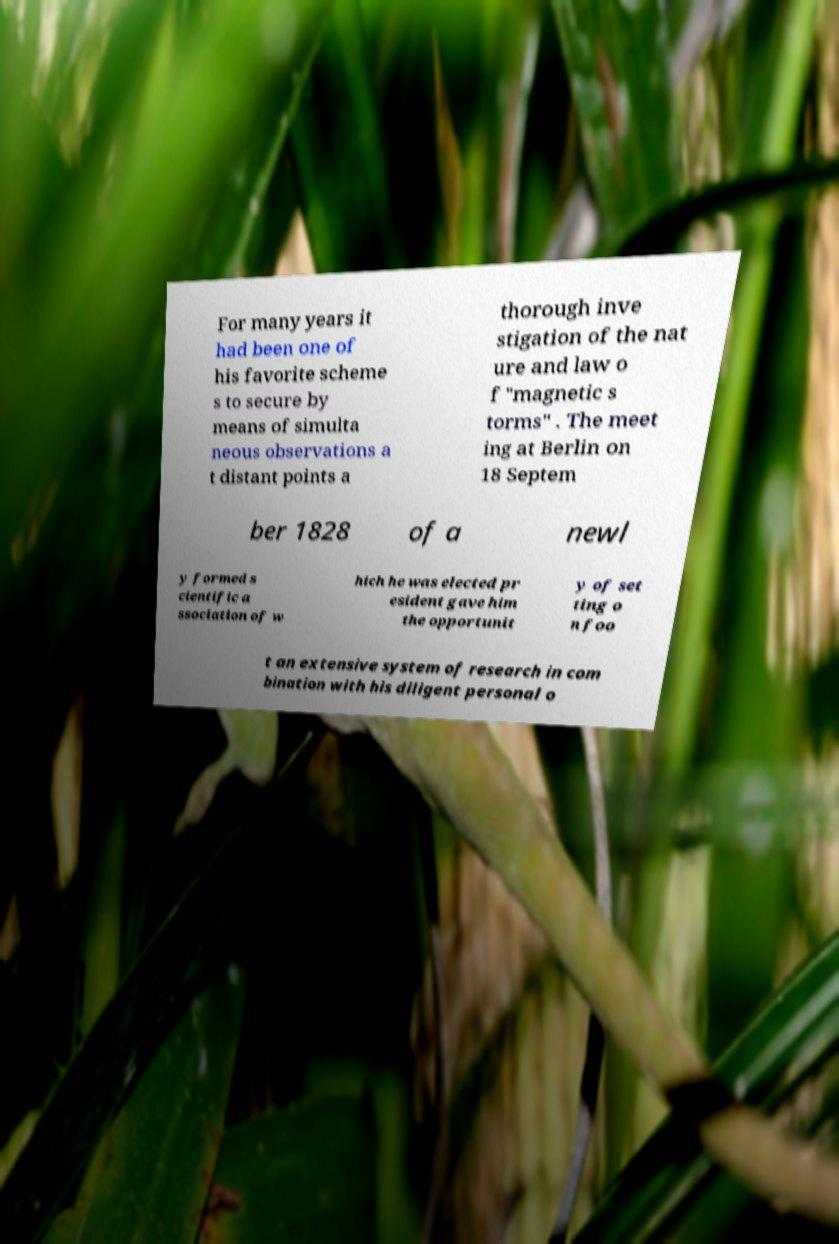Can you accurately transcribe the text from the provided image for me? For many years it had been one of his favorite scheme s to secure by means of simulta neous observations a t distant points a thorough inve stigation of the nat ure and law o f "magnetic s torms" . The meet ing at Berlin on 18 Septem ber 1828 of a newl y formed s cientific a ssociation of w hich he was elected pr esident gave him the opportunit y of set ting o n foo t an extensive system of research in com bination with his diligent personal o 